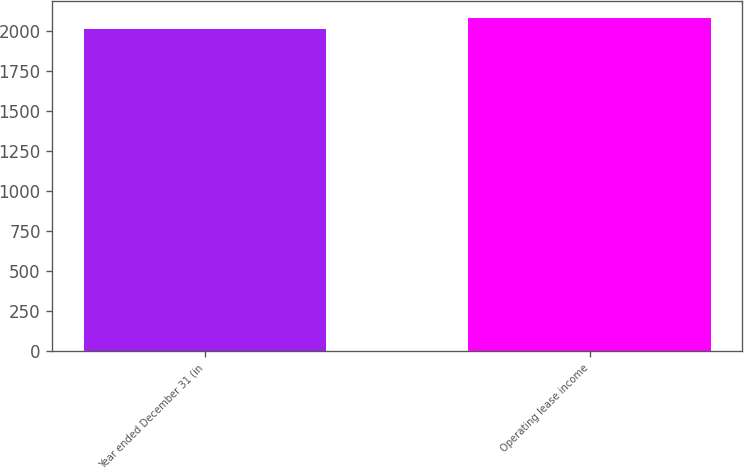Convert chart to OTSL. <chart><loc_0><loc_0><loc_500><loc_500><bar_chart><fcel>Year ended December 31 (in<fcel>Operating lease income<nl><fcel>2015<fcel>2081<nl></chart> 